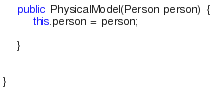<code> <loc_0><loc_0><loc_500><loc_500><_Java_>	public PhysicalModel(Person person) {
		this.person = person;
		
	}
	
	
}
</code> 